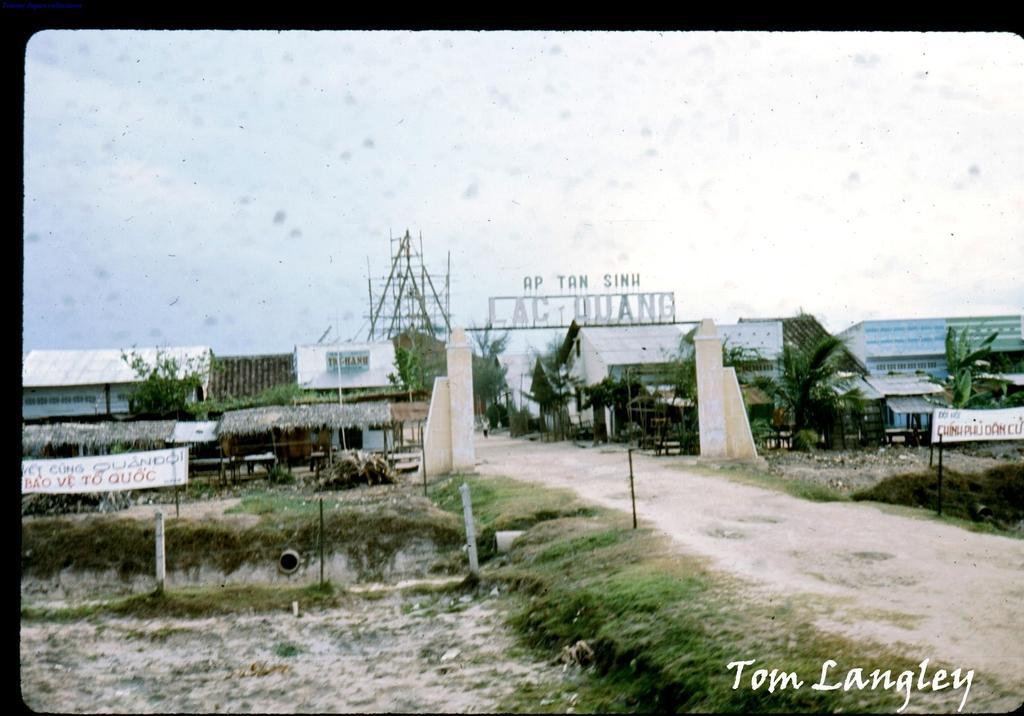Describe this image in one or two sentences. In the foreground of this poster, there is a path on the right and there is a name board to the pillars, buildings, trees and an another board. On the left, there are trees, poles, banners, huts, buildings and the sky. 